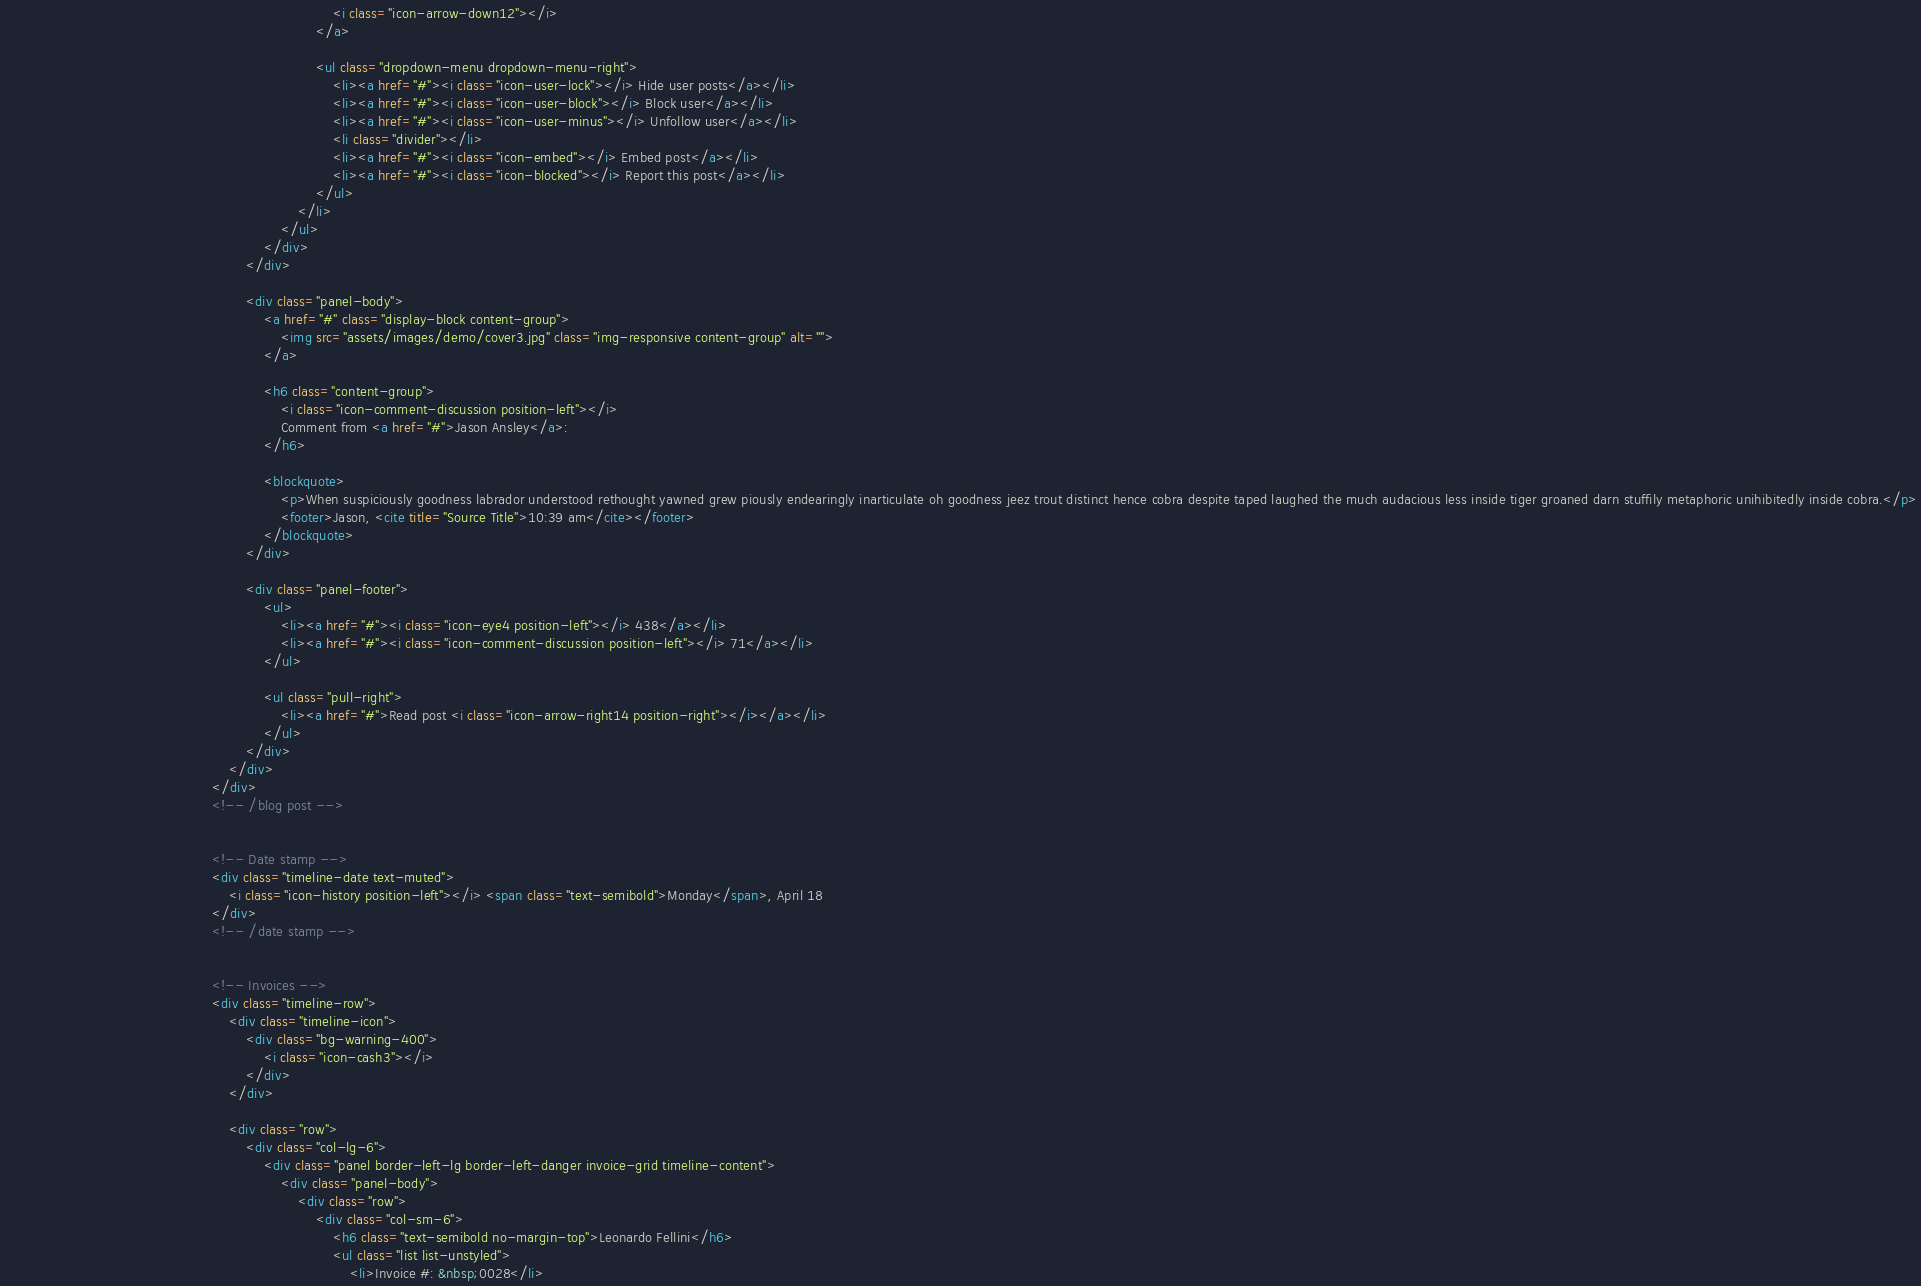<code> <loc_0><loc_0><loc_500><loc_500><_HTML_>																			<i class="icon-arrow-down12"></i>
																		</a>

																		<ul class="dropdown-menu dropdown-menu-right">
																			<li><a href="#"><i class="icon-user-lock"></i> Hide user posts</a></li>
																			<li><a href="#"><i class="icon-user-block"></i> Block user</a></li>
																			<li><a href="#"><i class="icon-user-minus"></i> Unfollow user</a></li>
																			<li class="divider"></li>
																			<li><a href="#"><i class="icon-embed"></i> Embed post</a></li>
																			<li><a href="#"><i class="icon-blocked"></i> Report this post</a></li>
																		</ul>
																	</li>
											                	</ul>
										                	</div>
														</div>

														<div class="panel-body">
															<a href="#" class="display-block content-group">
																<img src="assets/images/demo/cover3.jpg" class="img-responsive content-group" alt="">
															</a>

															<h6 class="content-group">
																<i class="icon-comment-discussion position-left"></i>
																Comment from <a href="#">Jason Ansley</a>:
															</h6>

															<blockquote>
																<p>When suspiciously goodness labrador understood rethought yawned grew piously endearingly inarticulate oh goodness jeez trout distinct hence cobra despite taped laughed the much audacious less inside tiger groaned darn stuffily metaphoric unihibitedly inside cobra.</p>
																<footer>Jason, <cite title="Source Title">10:39 am</cite></footer>
															</blockquote>
														</div>

														<div class="panel-footer">
															<ul>
																<li><a href="#"><i class="icon-eye4 position-left"></i> 438</a></li>
																<li><a href="#"><i class="icon-comment-discussion position-left"></i> 71</a></li>
															</ul>

															<ul class="pull-right">
																<li><a href="#">Read post <i class="icon-arrow-right14 position-right"></i></a></li>
															</ul>
														</div>
													</div>
												</div>
												<!-- /blog post -->


												<!-- Date stamp -->
												<div class="timeline-date text-muted">
													<i class="icon-history position-left"></i> <span class="text-semibold">Monday</span>, April 18
												</div>
												<!-- /date stamp -->


												<!-- Invoices -->
												<div class="timeline-row">
													<div class="timeline-icon">
														<div class="bg-warning-400">
															<i class="icon-cash3"></i>
														</div>
													</div>

													<div class="row">
														<div class="col-lg-6">
															<div class="panel border-left-lg border-left-danger invoice-grid timeline-content">
																<div class="panel-body">
																	<div class="row">
																		<div class="col-sm-6">
																			<h6 class="text-semibold no-margin-top">Leonardo Fellini</h6>
																			<ul class="list list-unstyled">
																				<li>Invoice #: &nbsp;0028</li></code> 